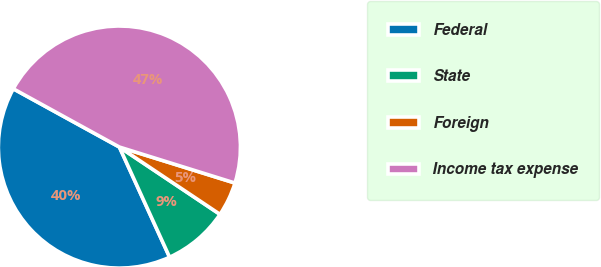Convert chart to OTSL. <chart><loc_0><loc_0><loc_500><loc_500><pie_chart><fcel>Federal<fcel>State<fcel>Foreign<fcel>Income tax expense<nl><fcel>39.8%<fcel>8.81%<fcel>4.58%<fcel>46.81%<nl></chart> 